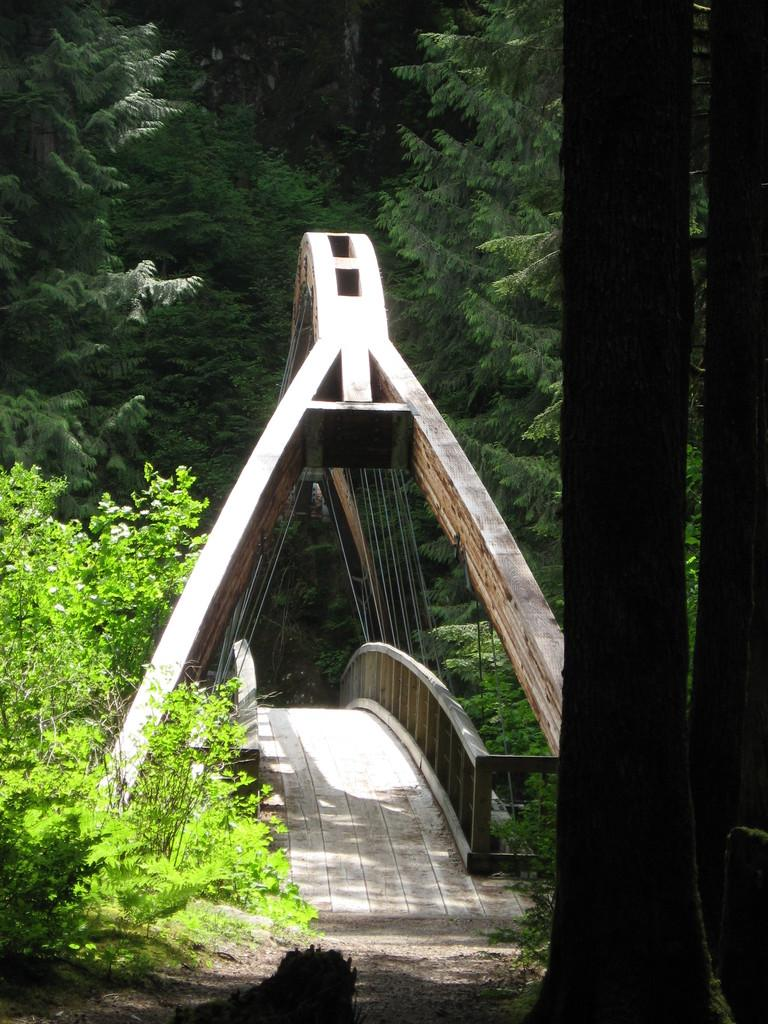What type of vegetation can be seen in the image? There are trees and plants in the image. Where are the stems located in the image? The stems are on the right side of the image. What structure is present in the middle of the image? There is a bridge in the middle of the image. Can you see any ghosts floating near the bridge in the image? No, there are no ghosts present in the image. What type of ocean can be seen in the image? There is no ocean visible in the image; it features trees, plants, stems, and a bridge. 